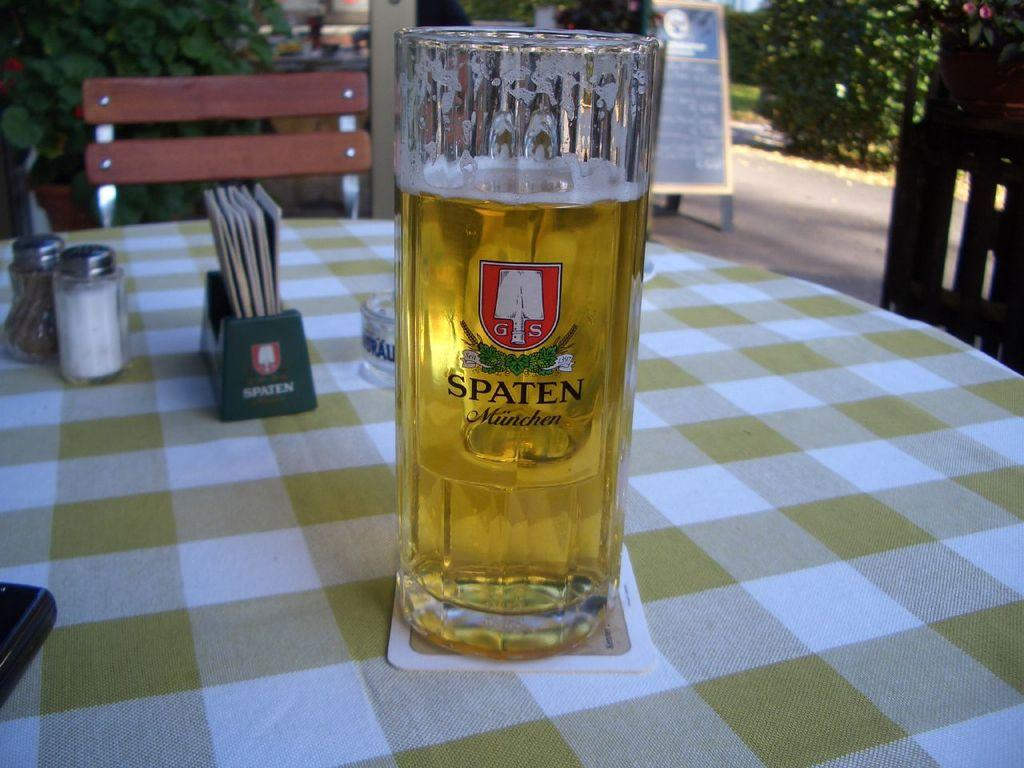<image>
Relay a brief, clear account of the picture shown. the word spaten is on the front of the beer 